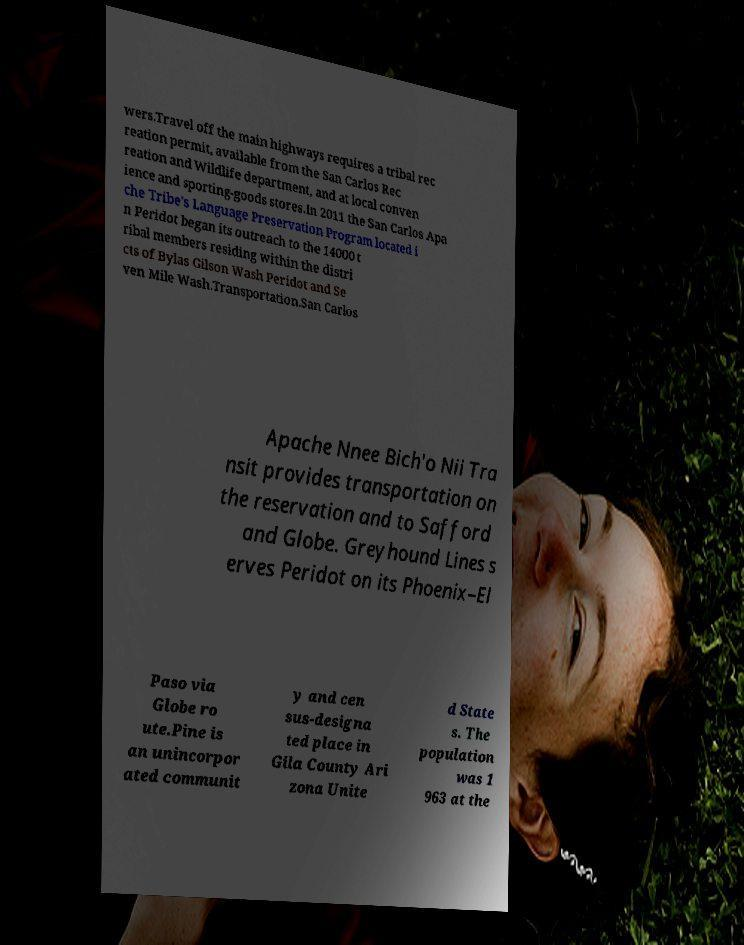There's text embedded in this image that I need extracted. Can you transcribe it verbatim? wers.Travel off the main highways requires a tribal rec reation permit, available from the San Carlos Rec reation and Wildlife department, and at local conven ience and sporting-goods stores.In 2011 the San Carlos Apa che Tribe's Language Preservation Program located i n Peridot began its outreach to the 14000 t ribal members residing within the distri cts of Bylas Gilson Wash Peridot and Se ven Mile Wash.Transportation.San Carlos Apache Nnee Bich'o Nii Tra nsit provides transportation on the reservation and to Safford and Globe. Greyhound Lines s erves Peridot on its Phoenix–El Paso via Globe ro ute.Pine is an unincorpor ated communit y and cen sus-designa ted place in Gila County Ari zona Unite d State s. The population was 1 963 at the 